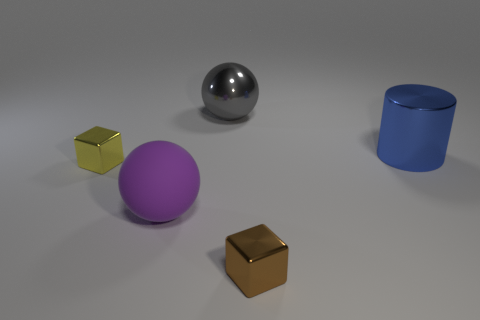Subtract all yellow blocks. How many blocks are left? 1 Add 4 large metal balls. How many objects exist? 9 Subtract 1 cylinders. How many cylinders are left? 0 Subtract all cylinders. How many objects are left? 4 Subtract all red cubes. Subtract all red spheres. How many cubes are left? 2 Subtract all red blocks. How many brown spheres are left? 0 Subtract all big brown rubber blocks. Subtract all purple spheres. How many objects are left? 4 Add 3 blocks. How many blocks are left? 5 Add 1 large red matte cubes. How many large red matte cubes exist? 1 Subtract 0 yellow cylinders. How many objects are left? 5 